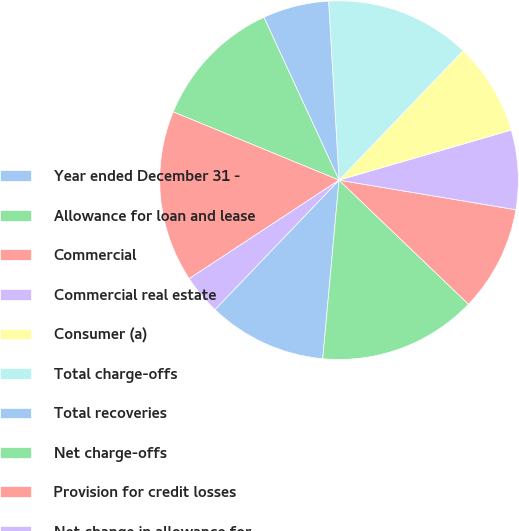<chart> <loc_0><loc_0><loc_500><loc_500><pie_chart><fcel>Year ended December 31 -<fcel>Allowance for loan and lease<fcel>Commercial<fcel>Commercial real estate<fcel>Consumer (a)<fcel>Total charge-offs<fcel>Total recoveries<fcel>Net charge-offs<fcel>Provision for credit losses<fcel>Net change in allowance for<nl><fcel>10.71%<fcel>14.28%<fcel>9.52%<fcel>7.14%<fcel>8.33%<fcel>13.09%<fcel>5.95%<fcel>11.9%<fcel>15.47%<fcel>3.58%<nl></chart> 